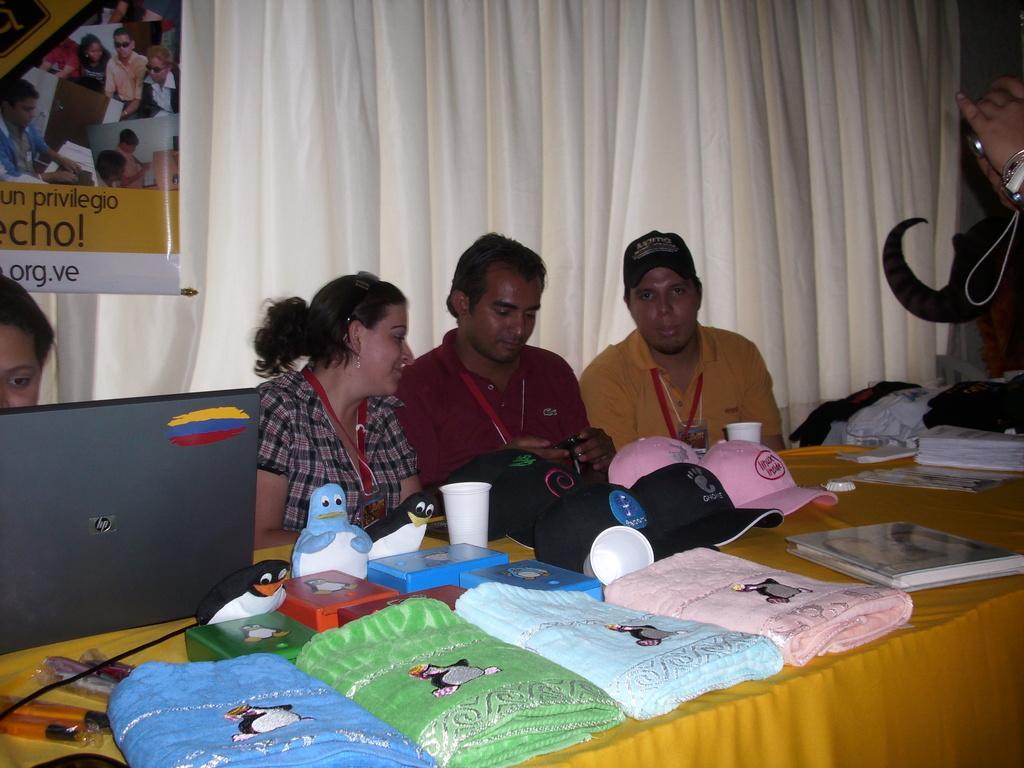In one or two sentences, can you explain what this image depicts? In the picture we can see some people are sitting near to the desk on the desk we can see a table cloth which is yellow in color on it we can see some dolls, caps, glasses, caps and some towels and they are wearing a tags and in the background we can see a white color curtain and beside it we can see a banner. 